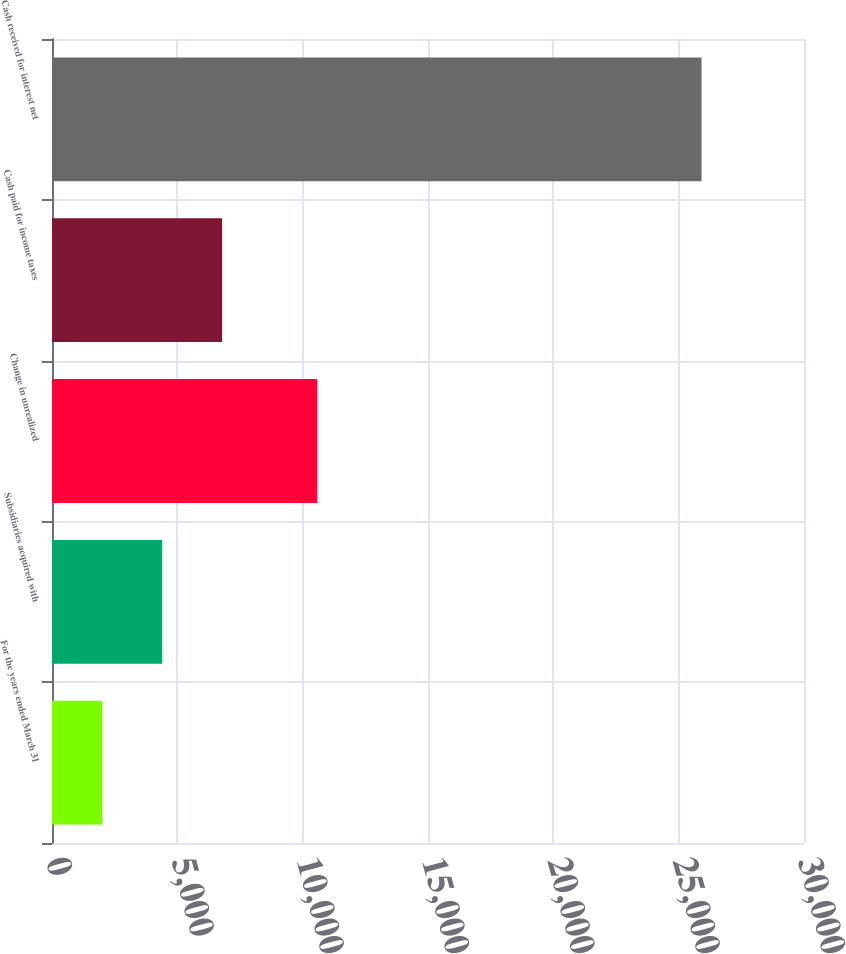<chart> <loc_0><loc_0><loc_500><loc_500><bar_chart><fcel>For the years ended March 31<fcel>Subsidiaries acquired with<fcel>Change in unrealized<fcel>Cash paid for income taxes<fcel>Cash received for interest net<nl><fcel>2006<fcel>4396.6<fcel>10576<fcel>6787.2<fcel>25912<nl></chart> 